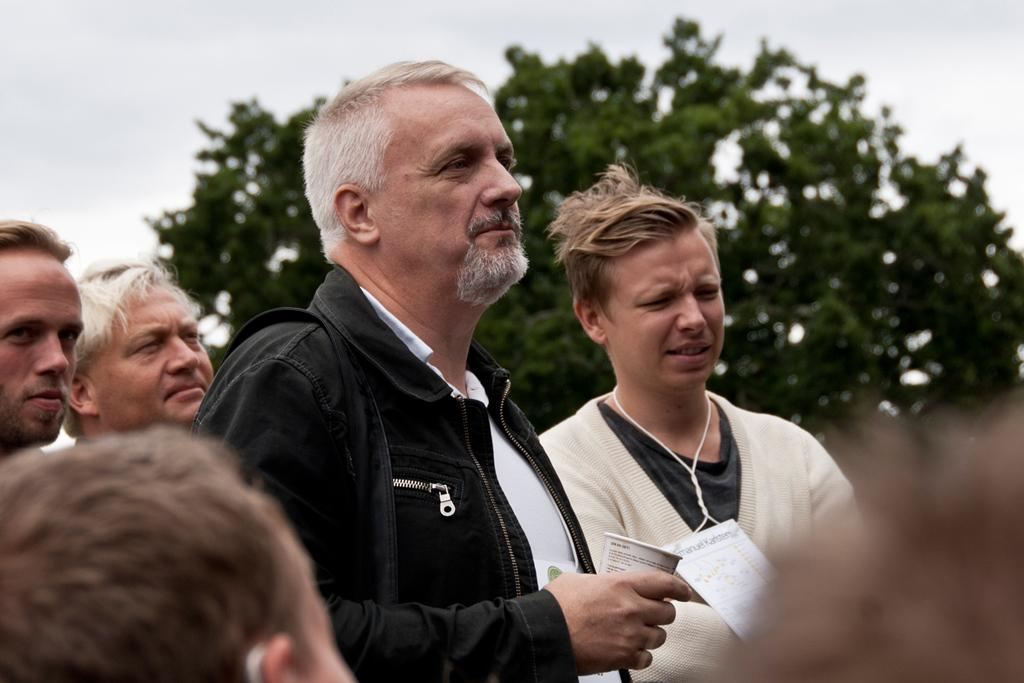How many people are present in the image? There are two persons standing in the image. What is the man holding in his hand? The man is holding a glass in his hand. Can you describe the group of people in the background? There is a group of persons standing in the background. What natural element can be seen in the image? There is a tree visible in the image. What is visible above the people and the tree? The sky is visible in the image. What type of humor can be seen in the expressions of the snails in the image? There are no snails present in the image, so it is not possible to determine their expressions or any humor associated with them. 